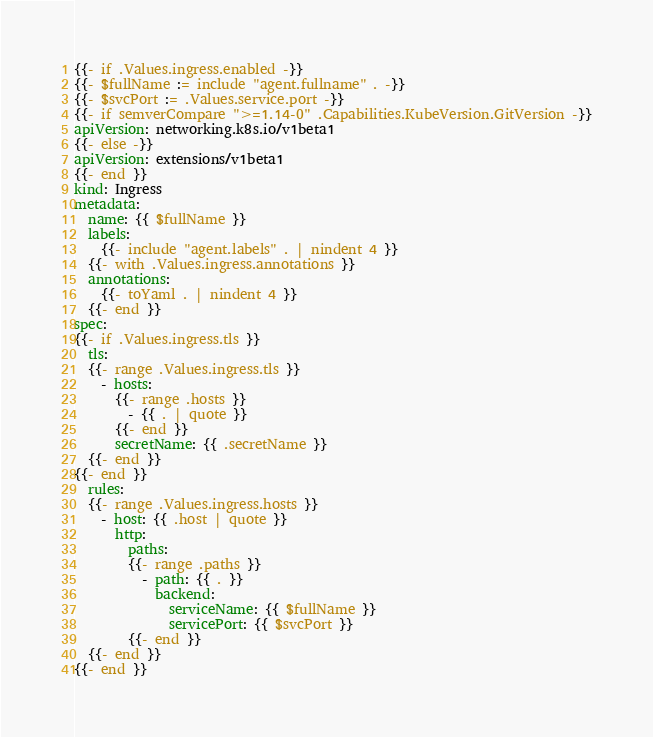<code> <loc_0><loc_0><loc_500><loc_500><_YAML_>{{- if .Values.ingress.enabled -}}
{{- $fullName := include "agent.fullname" . -}}
{{- $svcPort := .Values.service.port -}}
{{- if semverCompare ">=1.14-0" .Capabilities.KubeVersion.GitVersion -}}
apiVersion: networking.k8s.io/v1beta1
{{- else -}}
apiVersion: extensions/v1beta1
{{- end }}
kind: Ingress
metadata:
  name: {{ $fullName }}
  labels:
    {{- include "agent.labels" . | nindent 4 }}
  {{- with .Values.ingress.annotations }}
  annotations:
    {{- toYaml . | nindent 4 }}
  {{- end }}
spec:
{{- if .Values.ingress.tls }}
  tls:
  {{- range .Values.ingress.tls }}
    - hosts:
      {{- range .hosts }}
        - {{ . | quote }}
      {{- end }}
      secretName: {{ .secretName }}
  {{- end }}
{{- end }}
  rules:
  {{- range .Values.ingress.hosts }}
    - host: {{ .host | quote }}
      http:
        paths:
        {{- range .paths }}
          - path: {{ . }}
            backend:
              serviceName: {{ $fullName }}
              servicePort: {{ $svcPort }}
        {{- end }}
  {{- end }}
{{- end }}
</code> 